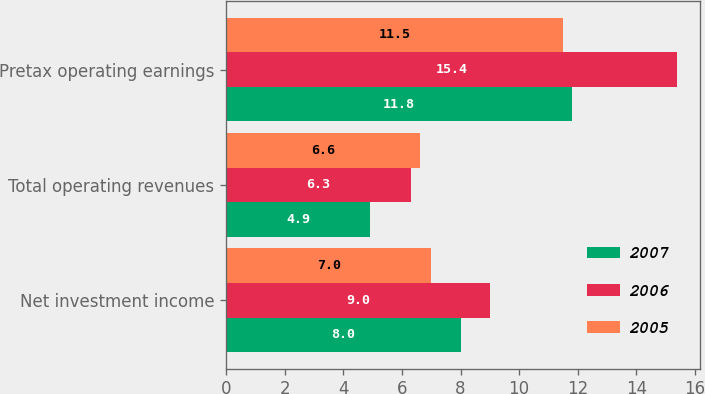Convert chart to OTSL. <chart><loc_0><loc_0><loc_500><loc_500><stacked_bar_chart><ecel><fcel>Net investment income<fcel>Total operating revenues<fcel>Pretax operating earnings<nl><fcel>2007<fcel>8<fcel>4.9<fcel>11.8<nl><fcel>2006<fcel>9<fcel>6.3<fcel>15.4<nl><fcel>2005<fcel>7<fcel>6.6<fcel>11.5<nl></chart> 